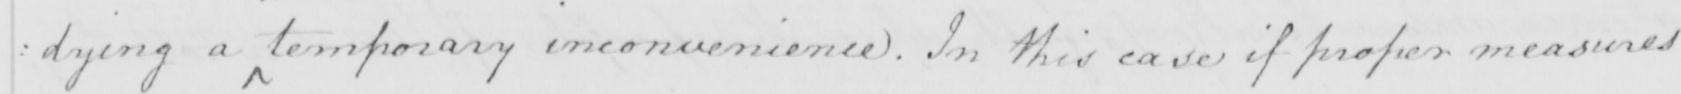What text is written in this handwritten line? : dying a temporary inconvenience . In this case if proper measures 